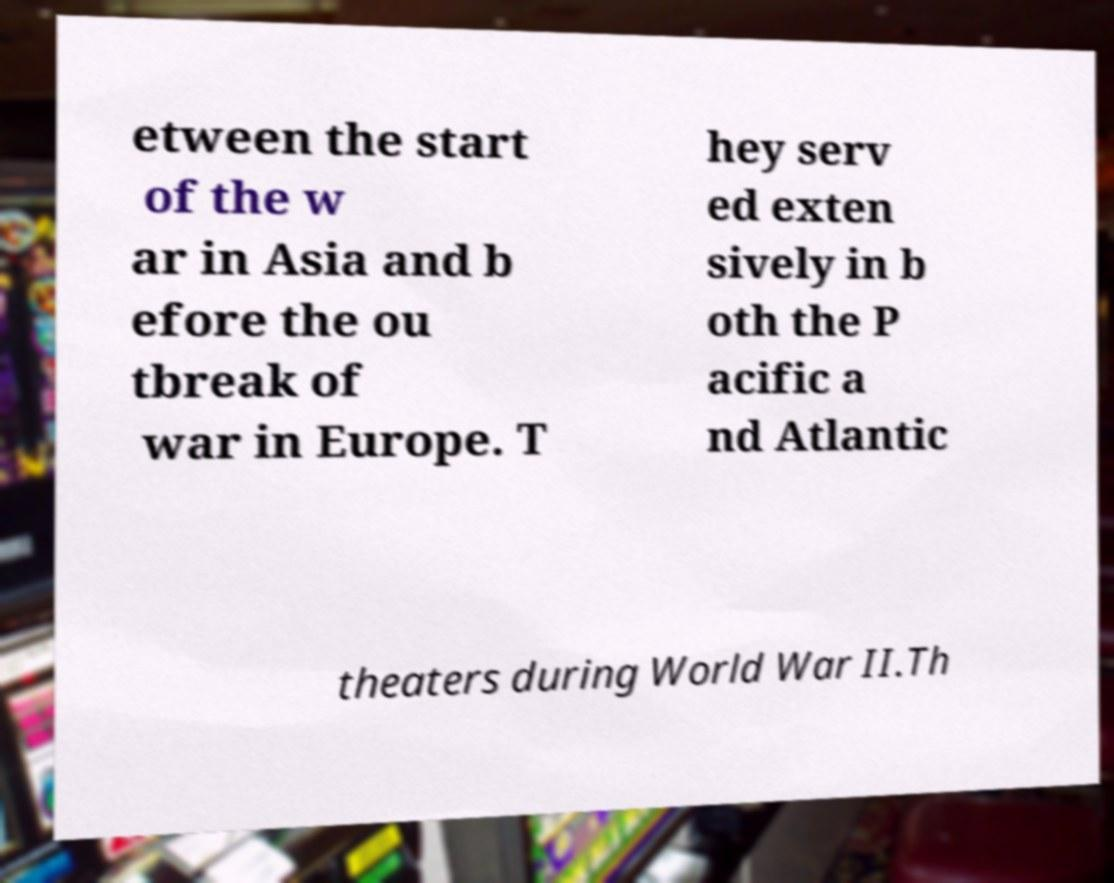Could you extract and type out the text from this image? etween the start of the w ar in Asia and b efore the ou tbreak of war in Europe. T hey serv ed exten sively in b oth the P acific a nd Atlantic theaters during World War II.Th 